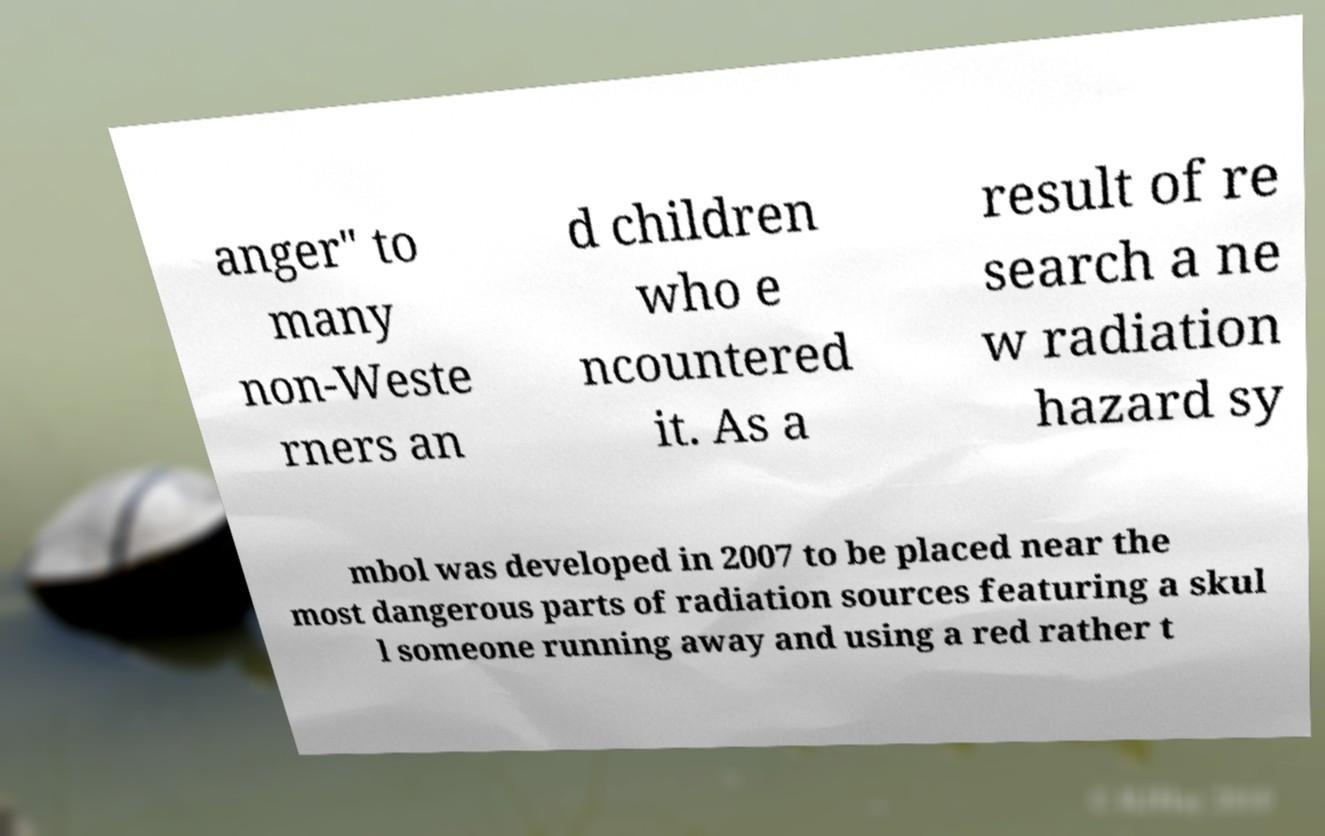Can you accurately transcribe the text from the provided image for me? anger" to many non-Weste rners an d children who e ncountered it. As a result of re search a ne w radiation hazard sy mbol was developed in 2007 to be placed near the most dangerous parts of radiation sources featuring a skul l someone running away and using a red rather t 